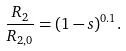Convert formula to latex. <formula><loc_0><loc_0><loc_500><loc_500>\frac { R _ { 2 } } { R _ { 2 , 0 } } = ( 1 - s ) ^ { 0 . 1 } .</formula> 